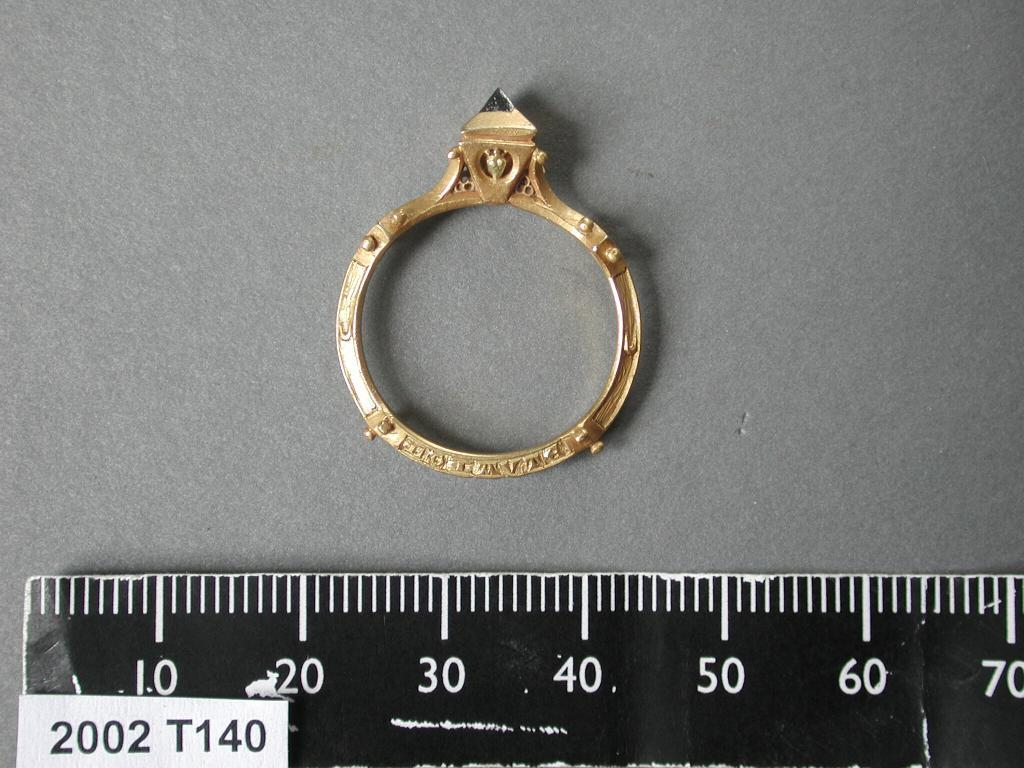<image>
Describe the image concisely. A ring is above a ruler showing the numbers 10 through 70 in increments of 10. 